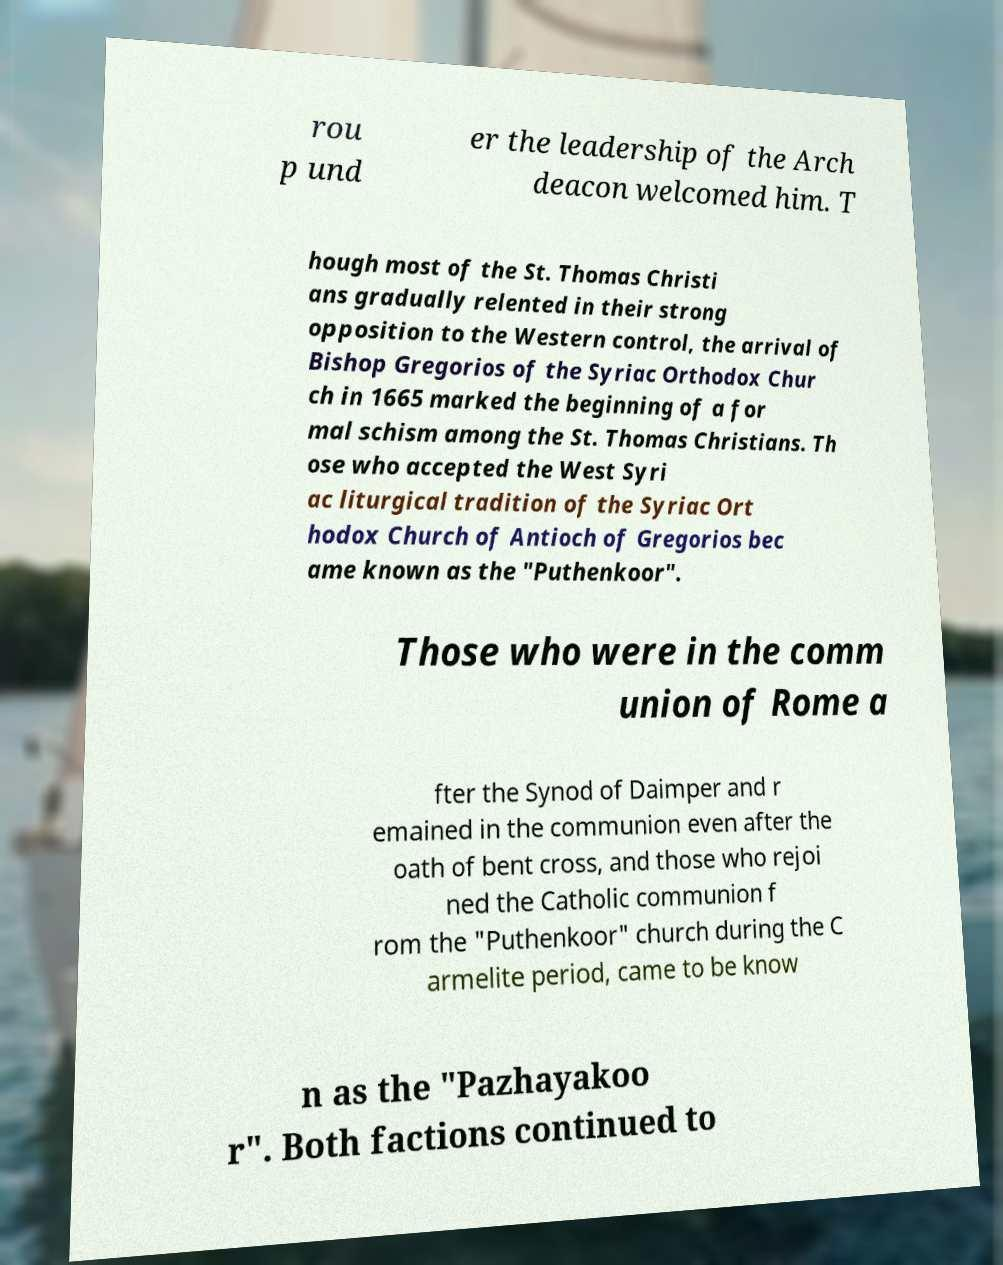Could you assist in decoding the text presented in this image and type it out clearly? rou p und er the leadership of the Arch deacon welcomed him. T hough most of the St. Thomas Christi ans gradually relented in their strong opposition to the Western control, the arrival of Bishop Gregorios of the Syriac Orthodox Chur ch in 1665 marked the beginning of a for mal schism among the St. Thomas Christians. Th ose who accepted the West Syri ac liturgical tradition of the Syriac Ort hodox Church of Antioch of Gregorios bec ame known as the "Puthenkoor". Those who were in the comm union of Rome a fter the Synod of Daimper and r emained in the communion even after the oath of bent cross, and those who rejoi ned the Catholic communion f rom the "Puthenkoor" church during the C armelite period, came to be know n as the "Pazhayakoo r". Both factions continued to 